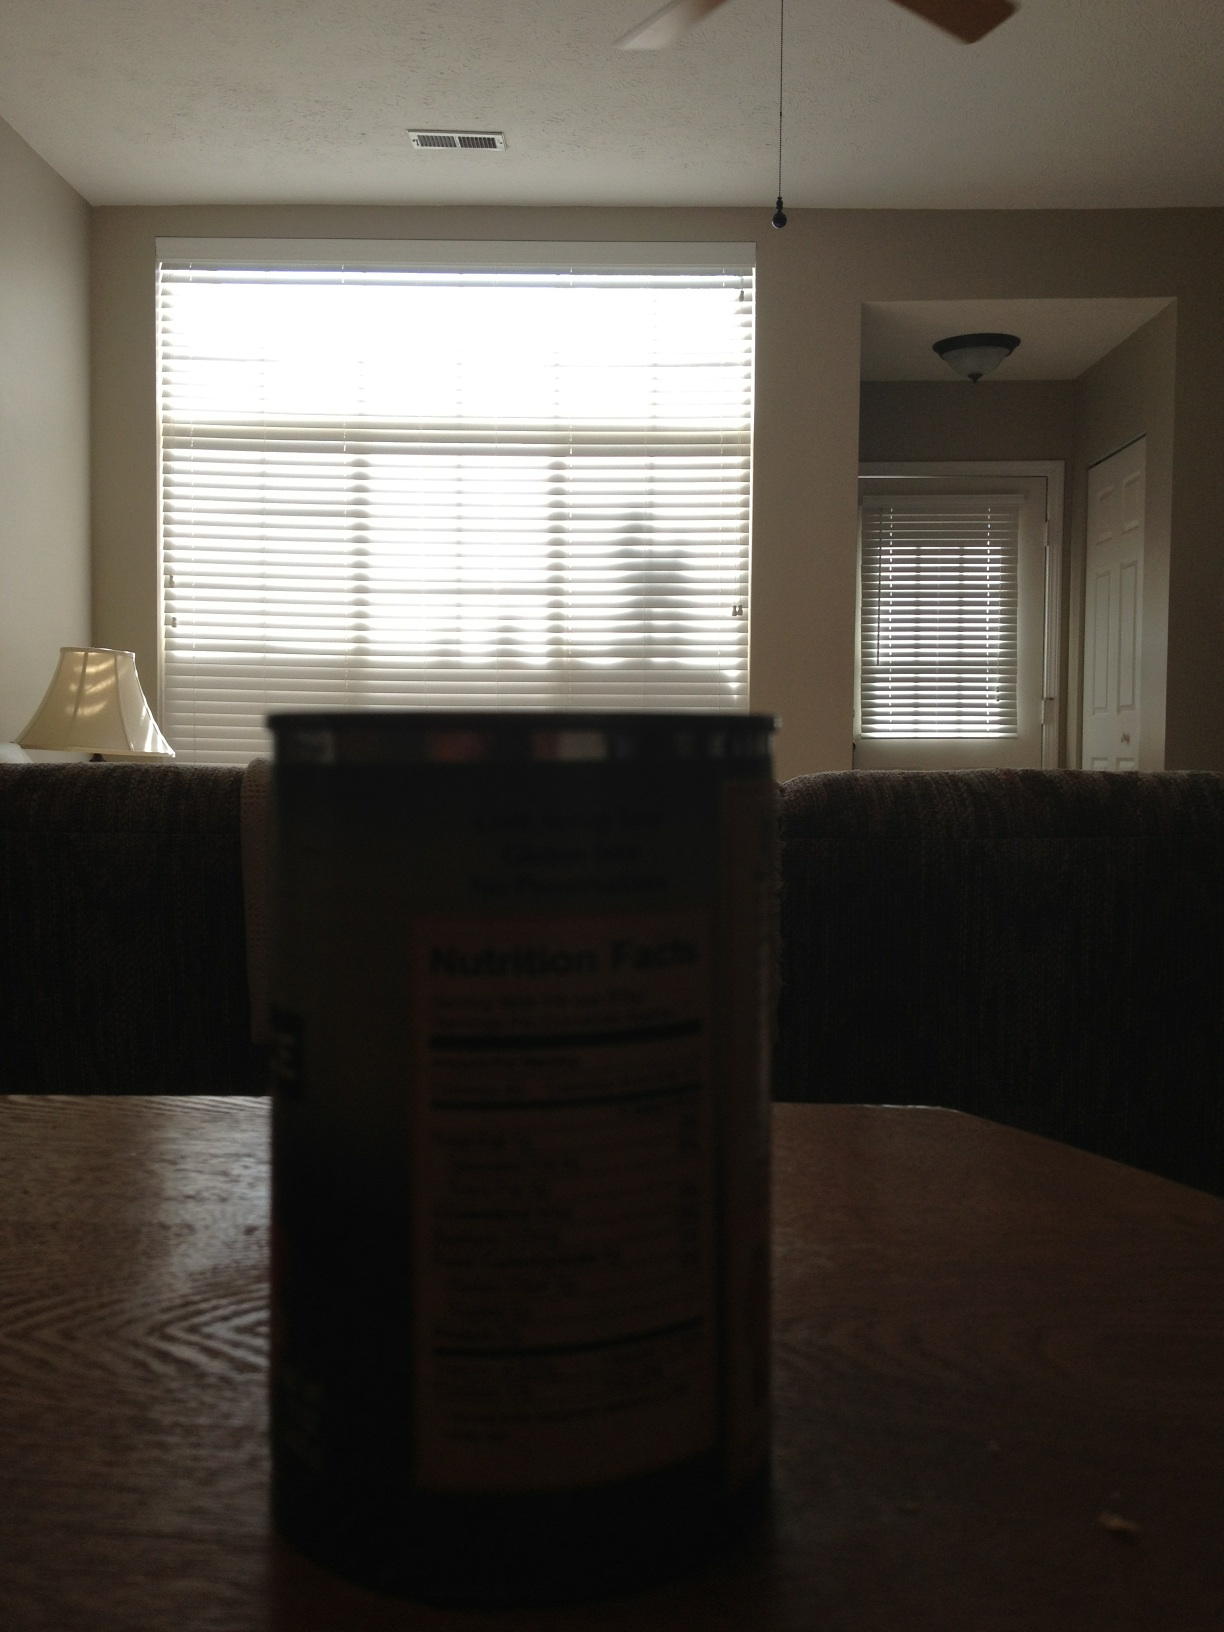If this room were a painting, what title would you give it and why? I would title the painting 'Afternoon Solitude.' The subdued lighting and the still environment suggest a moment of quiet reflection, perhaps capturing the essence of a peaceful afternoon spent at home. 